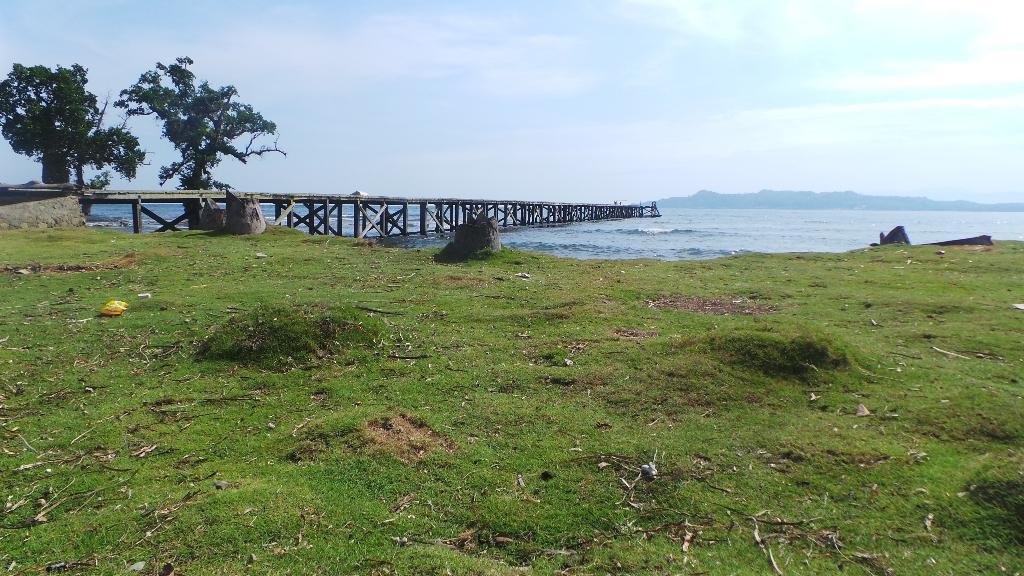What type of terrain is at the bottom of the image? There is grass at the bottom of the image. What can be seen on the left side of the image? There is a walkway on the left side of the image. What type of vegetation is present in the image? There are trees in the image. What is visible in the background of the image? There is a sea, hills, and the sky visible in the background. What type of advertisement can be seen on the grass in the image? There is no advertisement present on the grass in the image. What type of vessel is sailing on the sea in the image? There is no vessel visible on the sea in the image. 